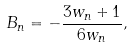Convert formula to latex. <formula><loc_0><loc_0><loc_500><loc_500>B _ { n } = - \frac { 3 w _ { n } + 1 } { 6 w _ { n } } ,</formula> 